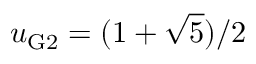Convert formula to latex. <formula><loc_0><loc_0><loc_500><loc_500>u _ { G 2 } = { ( 1 + \sqrt { 5 } ) / 2 }</formula> 